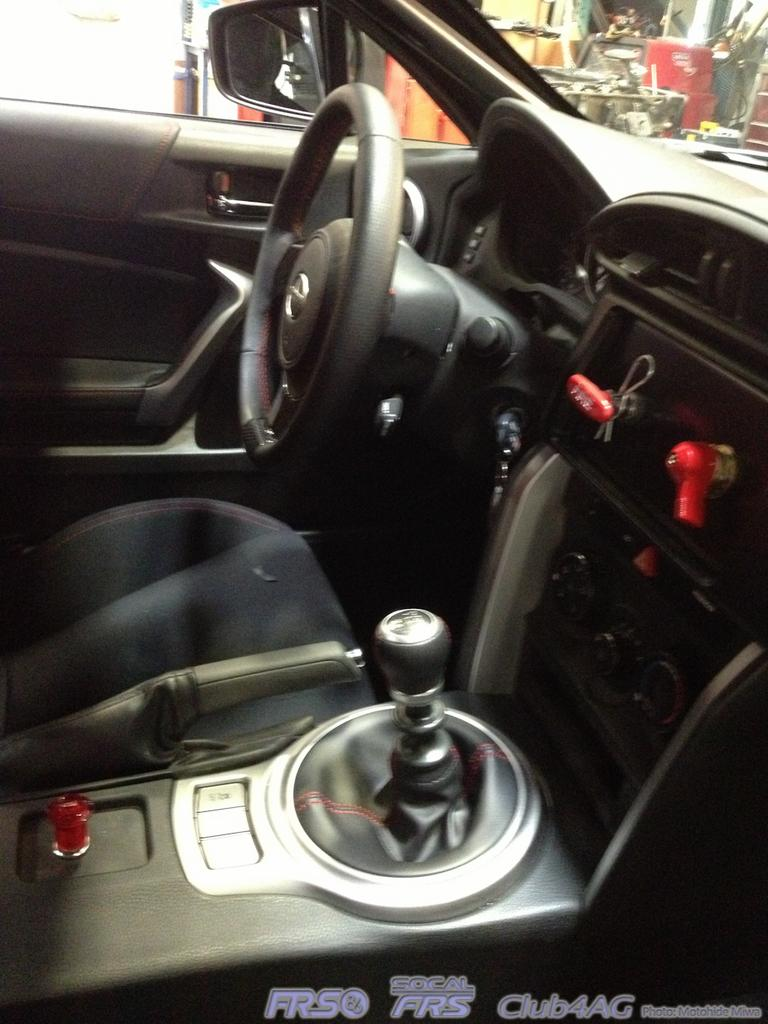What type of vehicle is shown in the image? The image shows an inner view of a car. What is a key component of the car's control system? The car contains a steering wheel. How does the driver control the car's speed and direction? The car has a gear system. What is provided for the driver to sit on? There is a seat in the car. What allows the driver to see the surroundings while driving? The car has windows. How does the driver check their appearance or monitor traffic behind them? A mirror is present in the car. Are there any pets visible in the car? There is no mention of pets in the image, so we cannot determine if any are present. What type of land can be seen through the car windows? The image does not show the view outside the car, so we cannot determine the type of land visible through the windows. 